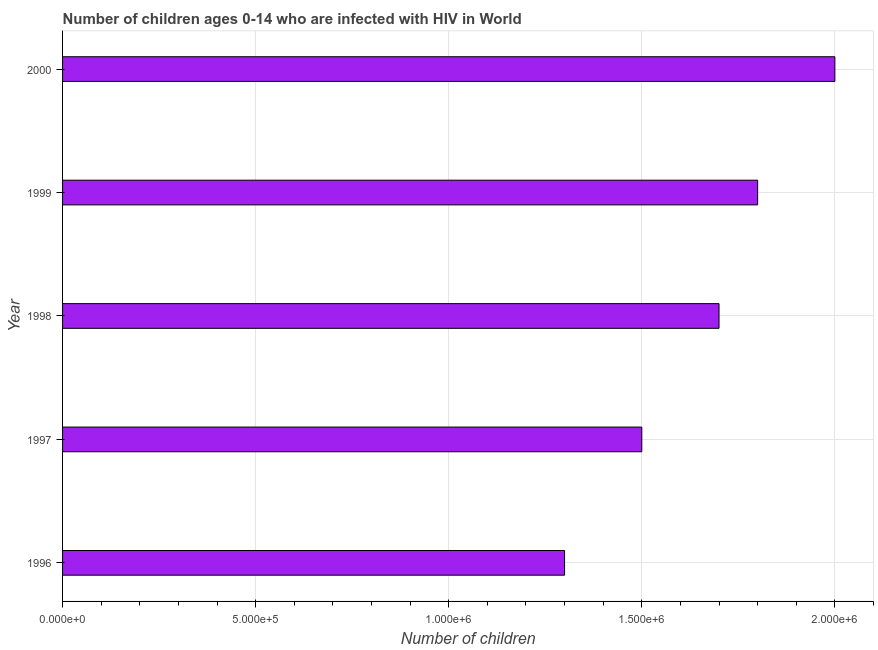Does the graph contain any zero values?
Offer a terse response. No. Does the graph contain grids?
Make the answer very short. Yes. What is the title of the graph?
Provide a short and direct response. Number of children ages 0-14 who are infected with HIV in World. What is the label or title of the X-axis?
Your answer should be very brief. Number of children. What is the label or title of the Y-axis?
Your answer should be very brief. Year. Across all years, what is the minimum number of children living with hiv?
Offer a very short reply. 1.30e+06. In which year was the number of children living with hiv maximum?
Offer a terse response. 2000. What is the sum of the number of children living with hiv?
Ensure brevity in your answer.  8.30e+06. What is the difference between the number of children living with hiv in 1998 and 1999?
Ensure brevity in your answer.  -1.00e+05. What is the average number of children living with hiv per year?
Your response must be concise. 1.66e+06. What is the median number of children living with hiv?
Offer a terse response. 1.70e+06. Do a majority of the years between 2000 and 1997 (inclusive) have number of children living with hiv greater than 500000 ?
Your answer should be compact. Yes. Is the number of children living with hiv in 1997 less than that in 1999?
Your response must be concise. Yes. Is the difference between the number of children living with hiv in 1996 and 1997 greater than the difference between any two years?
Give a very brief answer. No. Is the sum of the number of children living with hiv in 1997 and 2000 greater than the maximum number of children living with hiv across all years?
Keep it short and to the point. Yes. In how many years, is the number of children living with hiv greater than the average number of children living with hiv taken over all years?
Offer a terse response. 3. What is the difference between two consecutive major ticks on the X-axis?
Your answer should be very brief. 5.00e+05. Are the values on the major ticks of X-axis written in scientific E-notation?
Provide a short and direct response. Yes. What is the Number of children in 1996?
Your answer should be very brief. 1.30e+06. What is the Number of children of 1997?
Provide a short and direct response. 1.50e+06. What is the Number of children in 1998?
Make the answer very short. 1.70e+06. What is the Number of children of 1999?
Ensure brevity in your answer.  1.80e+06. What is the Number of children in 2000?
Give a very brief answer. 2.00e+06. What is the difference between the Number of children in 1996 and 1997?
Ensure brevity in your answer.  -2.00e+05. What is the difference between the Number of children in 1996 and 1998?
Your response must be concise. -4.00e+05. What is the difference between the Number of children in 1996 and 1999?
Give a very brief answer. -5.00e+05. What is the difference between the Number of children in 1996 and 2000?
Make the answer very short. -7.00e+05. What is the difference between the Number of children in 1997 and 2000?
Your answer should be compact. -5.00e+05. What is the difference between the Number of children in 1999 and 2000?
Offer a very short reply. -2.00e+05. What is the ratio of the Number of children in 1996 to that in 1997?
Offer a terse response. 0.87. What is the ratio of the Number of children in 1996 to that in 1998?
Give a very brief answer. 0.77. What is the ratio of the Number of children in 1996 to that in 1999?
Make the answer very short. 0.72. What is the ratio of the Number of children in 1996 to that in 2000?
Ensure brevity in your answer.  0.65. What is the ratio of the Number of children in 1997 to that in 1998?
Offer a terse response. 0.88. What is the ratio of the Number of children in 1997 to that in 1999?
Provide a succinct answer. 0.83. What is the ratio of the Number of children in 1998 to that in 1999?
Provide a short and direct response. 0.94. 